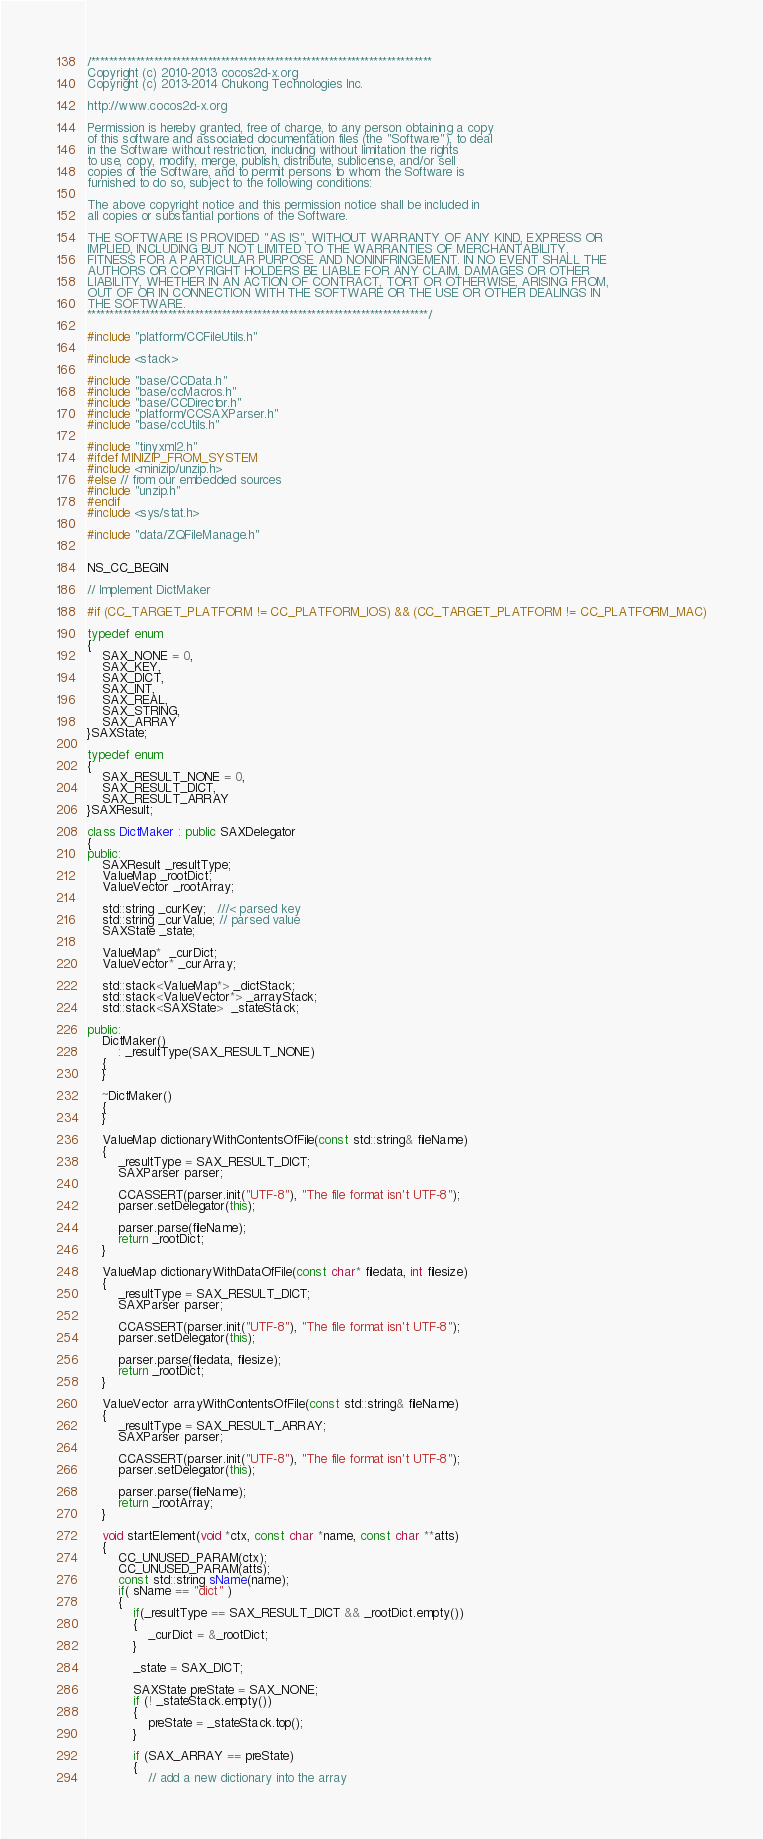Convert code to text. <code><loc_0><loc_0><loc_500><loc_500><_C++_>/****************************************************************************
Copyright (c) 2010-2013 cocos2d-x.org
Copyright (c) 2013-2014 Chukong Technologies Inc.

http://www.cocos2d-x.org

Permission is hereby granted, free of charge, to any person obtaining a copy
of this software and associated documentation files (the "Software"), to deal
in the Software without restriction, including without limitation the rights
to use, copy, modify, merge, publish, distribute, sublicense, and/or sell
copies of the Software, and to permit persons to whom the Software is
furnished to do so, subject to the following conditions:

The above copyright notice and this permission notice shall be included in
all copies or substantial portions of the Software.

THE SOFTWARE IS PROVIDED "AS IS", WITHOUT WARRANTY OF ANY KIND, EXPRESS OR
IMPLIED, INCLUDING BUT NOT LIMITED TO THE WARRANTIES OF MERCHANTABILITY,
FITNESS FOR A PARTICULAR PURPOSE AND NONINFRINGEMENT. IN NO EVENT SHALL THE
AUTHORS OR COPYRIGHT HOLDERS BE LIABLE FOR ANY CLAIM, DAMAGES OR OTHER
LIABILITY, WHETHER IN AN ACTION OF CONTRACT, TORT OR OTHERWISE, ARISING FROM,
OUT OF OR IN CONNECTION WITH THE SOFTWARE OR THE USE OR OTHER DEALINGS IN
THE SOFTWARE.
****************************************************************************/

#include "platform/CCFileUtils.h"

#include <stack>

#include "base/CCData.h"
#include "base/ccMacros.h"
#include "base/CCDirector.h"
#include "platform/CCSAXParser.h"
#include "base/ccUtils.h"

#include "tinyxml2.h"
#ifdef MINIZIP_FROM_SYSTEM
#include <minizip/unzip.h>
#else // from our embedded sources
#include "unzip.h"
#endif
#include <sys/stat.h>

#include "data/ZQFileManage.h"


NS_CC_BEGIN

// Implement DictMaker

#if (CC_TARGET_PLATFORM != CC_PLATFORM_IOS) && (CC_TARGET_PLATFORM != CC_PLATFORM_MAC)

typedef enum
{
    SAX_NONE = 0,
    SAX_KEY,
    SAX_DICT,
    SAX_INT,
    SAX_REAL,
    SAX_STRING,
    SAX_ARRAY
}SAXState;

typedef enum
{
    SAX_RESULT_NONE = 0,
    SAX_RESULT_DICT,
    SAX_RESULT_ARRAY
}SAXResult;

class DictMaker : public SAXDelegator
{
public:
    SAXResult _resultType;
    ValueMap _rootDict;
    ValueVector _rootArray;

    std::string _curKey;   ///< parsed key
    std::string _curValue; // parsed value
    SAXState _state;

    ValueMap*  _curDict;
    ValueVector* _curArray;

    std::stack<ValueMap*> _dictStack;
    std::stack<ValueVector*> _arrayStack;
    std::stack<SAXState>  _stateStack;

public:
    DictMaker()
        : _resultType(SAX_RESULT_NONE)
    {
    }

    ~DictMaker()
    {
    }

    ValueMap dictionaryWithContentsOfFile(const std::string& fileName)
    {
        _resultType = SAX_RESULT_DICT;
        SAXParser parser;

        CCASSERT(parser.init("UTF-8"), "The file format isn't UTF-8");
        parser.setDelegator(this);

        parser.parse(fileName);
        return _rootDict;
    }

    ValueMap dictionaryWithDataOfFile(const char* filedata, int filesize)
    {
        _resultType = SAX_RESULT_DICT;
        SAXParser parser;

        CCASSERT(parser.init("UTF-8"), "The file format isn't UTF-8");
        parser.setDelegator(this);

        parser.parse(filedata, filesize);
        return _rootDict;
    }

    ValueVector arrayWithContentsOfFile(const std::string& fileName)
    {
        _resultType = SAX_RESULT_ARRAY;
        SAXParser parser;

        CCASSERT(parser.init("UTF-8"), "The file format isn't UTF-8");
        parser.setDelegator(this);

        parser.parse(fileName);
        return _rootArray;
    }

    void startElement(void *ctx, const char *name, const char **atts)
    {
        CC_UNUSED_PARAM(ctx);
        CC_UNUSED_PARAM(atts);
        const std::string sName(name);
        if( sName == "dict" )
        {
            if(_resultType == SAX_RESULT_DICT && _rootDict.empty())
            {
                _curDict = &_rootDict;
            }

            _state = SAX_DICT;

            SAXState preState = SAX_NONE;
            if (! _stateStack.empty())
            {
                preState = _stateStack.top();
            }

            if (SAX_ARRAY == preState)
            {
                // add a new dictionary into the array</code> 